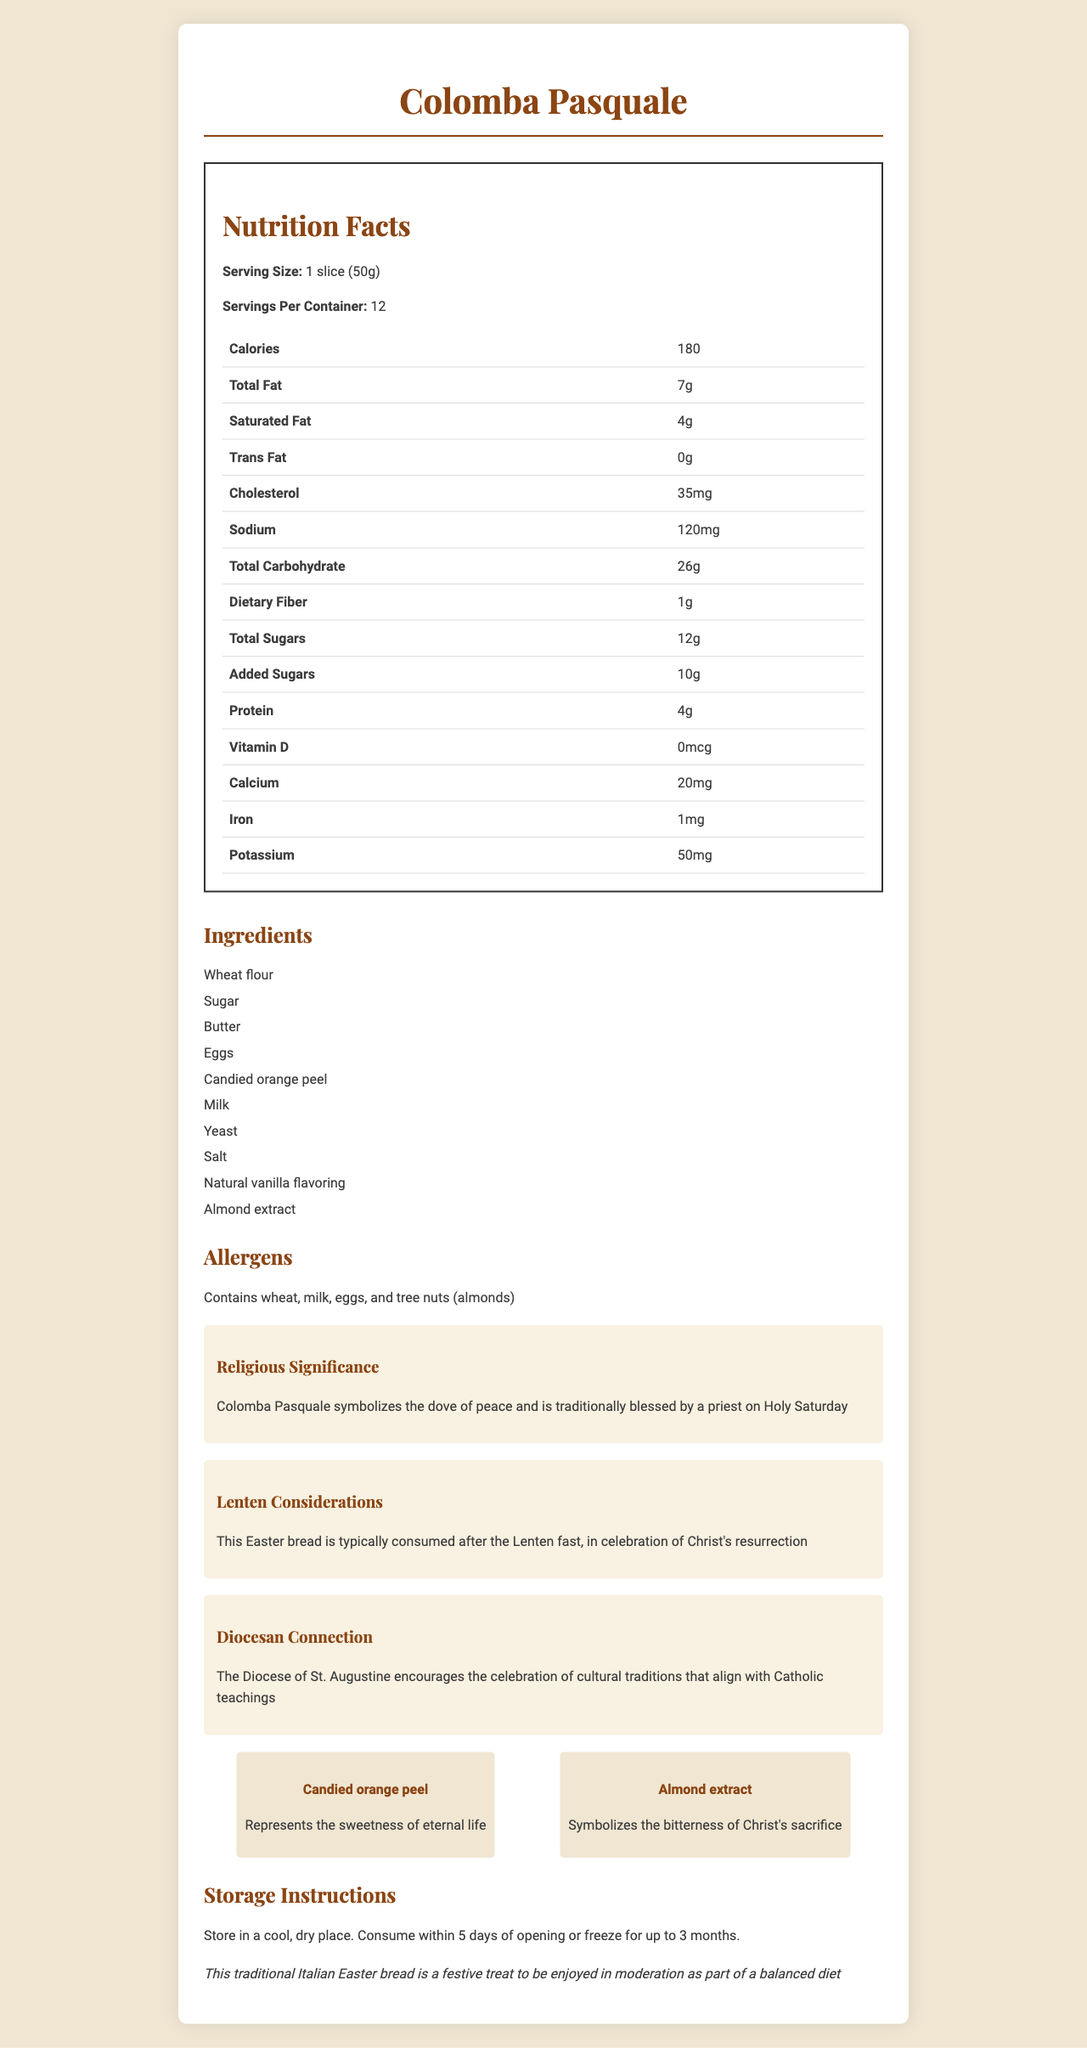what is the serving size of Colomba Pasquale? The serving size is provided at the top of the nutrition facts section as "1 slice (50g)".
Answer: 1 slice (50g) how many calories are in one serving? The number of calories per serving is listed as 180 calories in the table of nutrition facts.
Answer: 180 which vitamins and minerals are listed, and what are their amounts? These amounts are listed under their respective items in the nutrition facts table.
Answer: Vitamin D: 0mcg, Calcium: 20mg, Iron: 1mg, Potassium: 50mg how many grams of total carbohydrates are there per serving? The total carbohydrates per serving are listed as 26 grams in the nutrition facts.
Answer: 26 how is the product typically consumed and its significance in religious context? This information is described under "Lenten Considerations".
Answer: Consumed after the Lenten fast, symbolizing Christ's resurrection are there trans fats in this Easter bread? The nutrition facts table lists Trans Fat as 0 grams.
Answer: No how should Colomba Pasquale be stored? Storage instructions are provided at the end of the document.
Answer: Store in a cool, dry place. Consume within 5 days of opening or freeze for up to 3 months. how many servings are there per container? The number of servings per container is listed at the top of the nutrition facts section as 12 servings.
Answer: 12 what is the religious significance of Colomba Pasquale? This is detailed under "Religious Significance".
Answer: Symbolizes the dove of peace and is traditionally blessed by a priest on Holy Saturday does this product contain any allergens? The document states it contains wheat, milk, eggs, and tree nuts (almonds).
Answer: Yes which ingredient represents the sweetness of eternal life? A. Almond extract B. Milk C. Candied orange peel The document highlights festive ingredients and states that candied orange peel signifies the sweetness of eternal life.
Answer: C. Candied orange peel which ingredient symbolizes the bitterness of Christ's sacrifice? I. Milk II. Butter III. Almond extract IV. Yeast The document mentions almond extract symbolizes the bitterness of Christ's sacrifice.
Answer: III. Almond extract does this product contain added sugars? The nutrition facts table lists 10 grams of added sugars.
Answer: Yes what is the total fat content per serving? A. 5g B. 7g C. 9g D. 11g The total fat content is listed as 7 grams under the nutrition facts table.
Answer: B. 7g what is the main idea of this document? The entire document is centered around providing a comprehensive overview of the Colomba Pasquale, including its nutritional facts, ingredients, and cultural/religious context.
Answer: The document provides nutritional information, ingredients, storage instructions, religious significance, and festive ingredient symbolism for the traditional Italian Easter bread, Colomba Pasquale. how much cholesterol is in one serving? The amount of cholesterol per serving is listed as 35mg.
Answer: 35mg who encourages the celebration of this cultural tradition? The document states the Diocese of St. Augustine encourages the celebration of cultural traditions that align with Catholic teachings.
Answer: The Diocese of St. Augustine what is the exact amount of Vitamin D in Colomba Pasquale? The nutrition facts table lists 0mcg of Vitamin D.
Answer: 0mcg what are the Lenten considerations regarding this bread? This is detailed under the "Lenten Considerations" section.
Answer: Typical consumption after the Lenten fast, in celebration of Christ's resurrection how many grams of protein does one serving contain? A. 2g B. 4g C. 6g The nutrition facts table lists the protein content as 4 grams.
Answer: B. 4g is this bread gluten-free? The ingredients list includes wheat flour, indicating it is not gluten-free.
Answer: No how many days can you consume the bread after opening? The storage instructions indicate the bread should be consumed within 5 days of opening.
Answer: 5 days what is the exact amount of potassium in one serving? The amount of potassium per serving is listed as 50mg.
Answer: 50mg what type of extract is included in the ingredients? The ingredients list includes both almond extract and natural vanilla flavoring.
Answer: Almond extract and natural vanilla flavoring what is the frequency of Colomba Pasquale's traditional blessing by a priest? The document mentions it is traditionally blessed by a priest on Holy Saturday.
Answer: Once, on Holy Saturday which ingredient might those with tree nut allergies need to be cautious of? The list of allergens includes tree nuts (almonds), specifying almond extract as an ingredient.
Answer: Almond extract does the document provide the recipe to make Colomba Pasquale? The document only provides nutritional information, ingredients, and contextual details but does not include a recipe.
Answer: Cannot be determined 